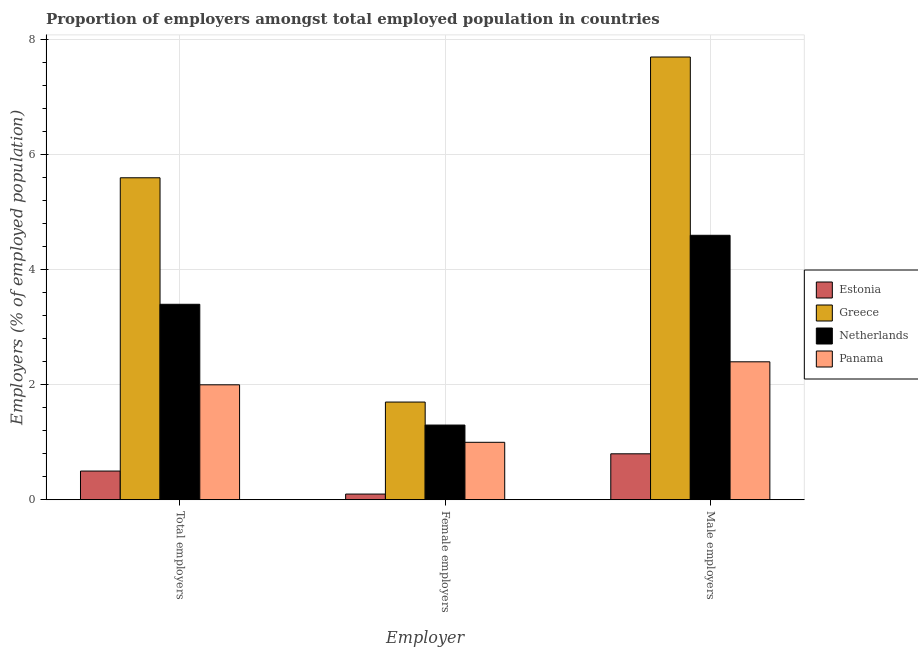How many different coloured bars are there?
Give a very brief answer. 4. How many groups of bars are there?
Offer a terse response. 3. How many bars are there on the 2nd tick from the right?
Your answer should be compact. 4. What is the label of the 3rd group of bars from the left?
Provide a succinct answer. Male employers. What is the percentage of total employers in Estonia?
Make the answer very short. 0.5. Across all countries, what is the maximum percentage of male employers?
Your answer should be very brief. 7.7. Across all countries, what is the minimum percentage of female employers?
Offer a terse response. 0.1. In which country was the percentage of male employers maximum?
Offer a very short reply. Greece. In which country was the percentage of male employers minimum?
Your answer should be compact. Estonia. What is the total percentage of male employers in the graph?
Give a very brief answer. 15.5. What is the difference between the percentage of male employers in Netherlands and that in Panama?
Ensure brevity in your answer.  2.2. What is the difference between the percentage of female employers in Greece and the percentage of male employers in Panama?
Provide a succinct answer. -0.7. What is the average percentage of male employers per country?
Ensure brevity in your answer.  3.87. What is the difference between the percentage of male employers and percentage of total employers in Netherlands?
Offer a very short reply. 1.2. What is the ratio of the percentage of female employers in Greece to that in Netherlands?
Your answer should be compact. 1.31. Is the difference between the percentage of male employers in Estonia and Greece greater than the difference between the percentage of female employers in Estonia and Greece?
Ensure brevity in your answer.  No. What is the difference between the highest and the second highest percentage of male employers?
Keep it short and to the point. 3.1. What is the difference between the highest and the lowest percentage of male employers?
Your answer should be compact. 6.9. In how many countries, is the percentage of total employers greater than the average percentage of total employers taken over all countries?
Provide a short and direct response. 2. Is the sum of the percentage of total employers in Greece and Panama greater than the maximum percentage of female employers across all countries?
Keep it short and to the point. Yes. What does the 2nd bar from the left in Total employers represents?
Provide a succinct answer. Greece. Is it the case that in every country, the sum of the percentage of total employers and percentage of female employers is greater than the percentage of male employers?
Your response must be concise. No. What is the difference between two consecutive major ticks on the Y-axis?
Provide a short and direct response. 2. Does the graph contain any zero values?
Offer a very short reply. No. Where does the legend appear in the graph?
Provide a succinct answer. Center right. How many legend labels are there?
Provide a succinct answer. 4. How are the legend labels stacked?
Offer a very short reply. Vertical. What is the title of the graph?
Keep it short and to the point. Proportion of employers amongst total employed population in countries. Does "Europe(all income levels)" appear as one of the legend labels in the graph?
Offer a very short reply. No. What is the label or title of the X-axis?
Offer a terse response. Employer. What is the label or title of the Y-axis?
Provide a succinct answer. Employers (% of employed population). What is the Employers (% of employed population) in Greece in Total employers?
Offer a very short reply. 5.6. What is the Employers (% of employed population) in Netherlands in Total employers?
Offer a terse response. 3.4. What is the Employers (% of employed population) in Estonia in Female employers?
Keep it short and to the point. 0.1. What is the Employers (% of employed population) in Greece in Female employers?
Provide a short and direct response. 1.7. What is the Employers (% of employed population) in Netherlands in Female employers?
Your response must be concise. 1.3. What is the Employers (% of employed population) in Estonia in Male employers?
Keep it short and to the point. 0.8. What is the Employers (% of employed population) in Greece in Male employers?
Provide a short and direct response. 7.7. What is the Employers (% of employed population) in Netherlands in Male employers?
Ensure brevity in your answer.  4.6. What is the Employers (% of employed population) in Panama in Male employers?
Your answer should be compact. 2.4. Across all Employer, what is the maximum Employers (% of employed population) in Estonia?
Provide a short and direct response. 0.8. Across all Employer, what is the maximum Employers (% of employed population) in Greece?
Keep it short and to the point. 7.7. Across all Employer, what is the maximum Employers (% of employed population) in Netherlands?
Ensure brevity in your answer.  4.6. Across all Employer, what is the maximum Employers (% of employed population) in Panama?
Offer a very short reply. 2.4. Across all Employer, what is the minimum Employers (% of employed population) of Estonia?
Give a very brief answer. 0.1. Across all Employer, what is the minimum Employers (% of employed population) of Greece?
Ensure brevity in your answer.  1.7. Across all Employer, what is the minimum Employers (% of employed population) of Netherlands?
Provide a succinct answer. 1.3. Across all Employer, what is the minimum Employers (% of employed population) of Panama?
Provide a short and direct response. 1. What is the total Employers (% of employed population) in Greece in the graph?
Offer a terse response. 15. What is the total Employers (% of employed population) in Panama in the graph?
Your answer should be very brief. 5.4. What is the difference between the Employers (% of employed population) in Greece in Total employers and that in Female employers?
Your response must be concise. 3.9. What is the difference between the Employers (% of employed population) of Panama in Total employers and that in Female employers?
Offer a very short reply. 1. What is the difference between the Employers (% of employed population) in Greece in Total employers and that in Male employers?
Offer a terse response. -2.1. What is the difference between the Employers (% of employed population) of Netherlands in Total employers and that in Male employers?
Offer a terse response. -1.2. What is the difference between the Employers (% of employed population) of Estonia in Female employers and that in Male employers?
Your response must be concise. -0.7. What is the difference between the Employers (% of employed population) in Greece in Female employers and that in Male employers?
Ensure brevity in your answer.  -6. What is the difference between the Employers (% of employed population) in Estonia in Total employers and the Employers (% of employed population) in Greece in Female employers?
Your response must be concise. -1.2. What is the difference between the Employers (% of employed population) in Estonia in Total employers and the Employers (% of employed population) in Netherlands in Female employers?
Offer a very short reply. -0.8. What is the difference between the Employers (% of employed population) of Estonia in Total employers and the Employers (% of employed population) of Panama in Female employers?
Ensure brevity in your answer.  -0.5. What is the difference between the Employers (% of employed population) of Greece in Total employers and the Employers (% of employed population) of Netherlands in Female employers?
Keep it short and to the point. 4.3. What is the difference between the Employers (% of employed population) of Netherlands in Total employers and the Employers (% of employed population) of Panama in Female employers?
Your answer should be very brief. 2.4. What is the difference between the Employers (% of employed population) of Greece in Total employers and the Employers (% of employed population) of Netherlands in Male employers?
Provide a short and direct response. 1. What is the difference between the Employers (% of employed population) of Netherlands in Total employers and the Employers (% of employed population) of Panama in Male employers?
Your answer should be very brief. 1. What is the difference between the Employers (% of employed population) of Estonia in Female employers and the Employers (% of employed population) of Greece in Male employers?
Make the answer very short. -7.6. What is the difference between the Employers (% of employed population) in Estonia in Female employers and the Employers (% of employed population) in Netherlands in Male employers?
Provide a succinct answer. -4.5. What is the difference between the Employers (% of employed population) in Estonia in Female employers and the Employers (% of employed population) in Panama in Male employers?
Your answer should be compact. -2.3. What is the difference between the Employers (% of employed population) of Greece in Female employers and the Employers (% of employed population) of Netherlands in Male employers?
Keep it short and to the point. -2.9. What is the average Employers (% of employed population) of Estonia per Employer?
Your answer should be compact. 0.47. What is the average Employers (% of employed population) in Netherlands per Employer?
Provide a short and direct response. 3.1. What is the difference between the Employers (% of employed population) in Estonia and Employers (% of employed population) in Netherlands in Total employers?
Make the answer very short. -2.9. What is the difference between the Employers (% of employed population) of Estonia and Employers (% of employed population) of Panama in Total employers?
Your answer should be compact. -1.5. What is the difference between the Employers (% of employed population) in Netherlands and Employers (% of employed population) in Panama in Total employers?
Offer a very short reply. 1.4. What is the difference between the Employers (% of employed population) of Estonia and Employers (% of employed population) of Greece in Female employers?
Give a very brief answer. -1.6. What is the difference between the Employers (% of employed population) in Estonia and Employers (% of employed population) in Netherlands in Female employers?
Your answer should be compact. -1.2. What is the difference between the Employers (% of employed population) in Greece and Employers (% of employed population) in Netherlands in Female employers?
Your answer should be compact. 0.4. What is the difference between the Employers (% of employed population) in Greece and Employers (% of employed population) in Panama in Female employers?
Provide a succinct answer. 0.7. What is the difference between the Employers (% of employed population) of Estonia and Employers (% of employed population) of Greece in Male employers?
Provide a succinct answer. -6.9. What is the difference between the Employers (% of employed population) in Greece and Employers (% of employed population) in Netherlands in Male employers?
Provide a succinct answer. 3.1. What is the difference between the Employers (% of employed population) of Netherlands and Employers (% of employed population) of Panama in Male employers?
Provide a short and direct response. 2.2. What is the ratio of the Employers (% of employed population) of Greece in Total employers to that in Female employers?
Your answer should be very brief. 3.29. What is the ratio of the Employers (% of employed population) of Netherlands in Total employers to that in Female employers?
Offer a very short reply. 2.62. What is the ratio of the Employers (% of employed population) of Panama in Total employers to that in Female employers?
Your answer should be compact. 2. What is the ratio of the Employers (% of employed population) of Estonia in Total employers to that in Male employers?
Your answer should be very brief. 0.62. What is the ratio of the Employers (% of employed population) of Greece in Total employers to that in Male employers?
Offer a terse response. 0.73. What is the ratio of the Employers (% of employed population) in Netherlands in Total employers to that in Male employers?
Your answer should be very brief. 0.74. What is the ratio of the Employers (% of employed population) of Estonia in Female employers to that in Male employers?
Your response must be concise. 0.12. What is the ratio of the Employers (% of employed population) in Greece in Female employers to that in Male employers?
Offer a very short reply. 0.22. What is the ratio of the Employers (% of employed population) of Netherlands in Female employers to that in Male employers?
Make the answer very short. 0.28. What is the ratio of the Employers (% of employed population) in Panama in Female employers to that in Male employers?
Your answer should be very brief. 0.42. What is the difference between the highest and the second highest Employers (% of employed population) of Greece?
Ensure brevity in your answer.  2.1. What is the difference between the highest and the lowest Employers (% of employed population) of Netherlands?
Provide a short and direct response. 3.3. 